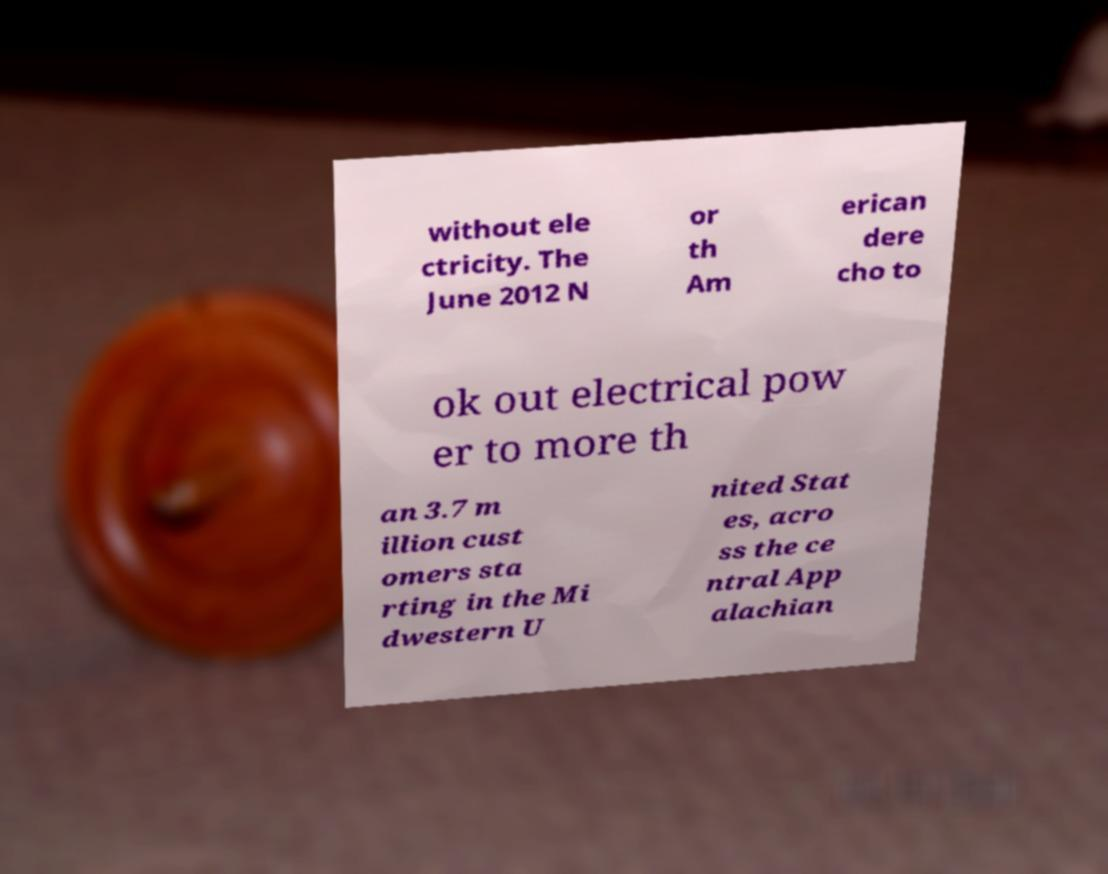For documentation purposes, I need the text within this image transcribed. Could you provide that? without ele ctricity. The June 2012 N or th Am erican dere cho to ok out electrical pow er to more th an 3.7 m illion cust omers sta rting in the Mi dwestern U nited Stat es, acro ss the ce ntral App alachian 